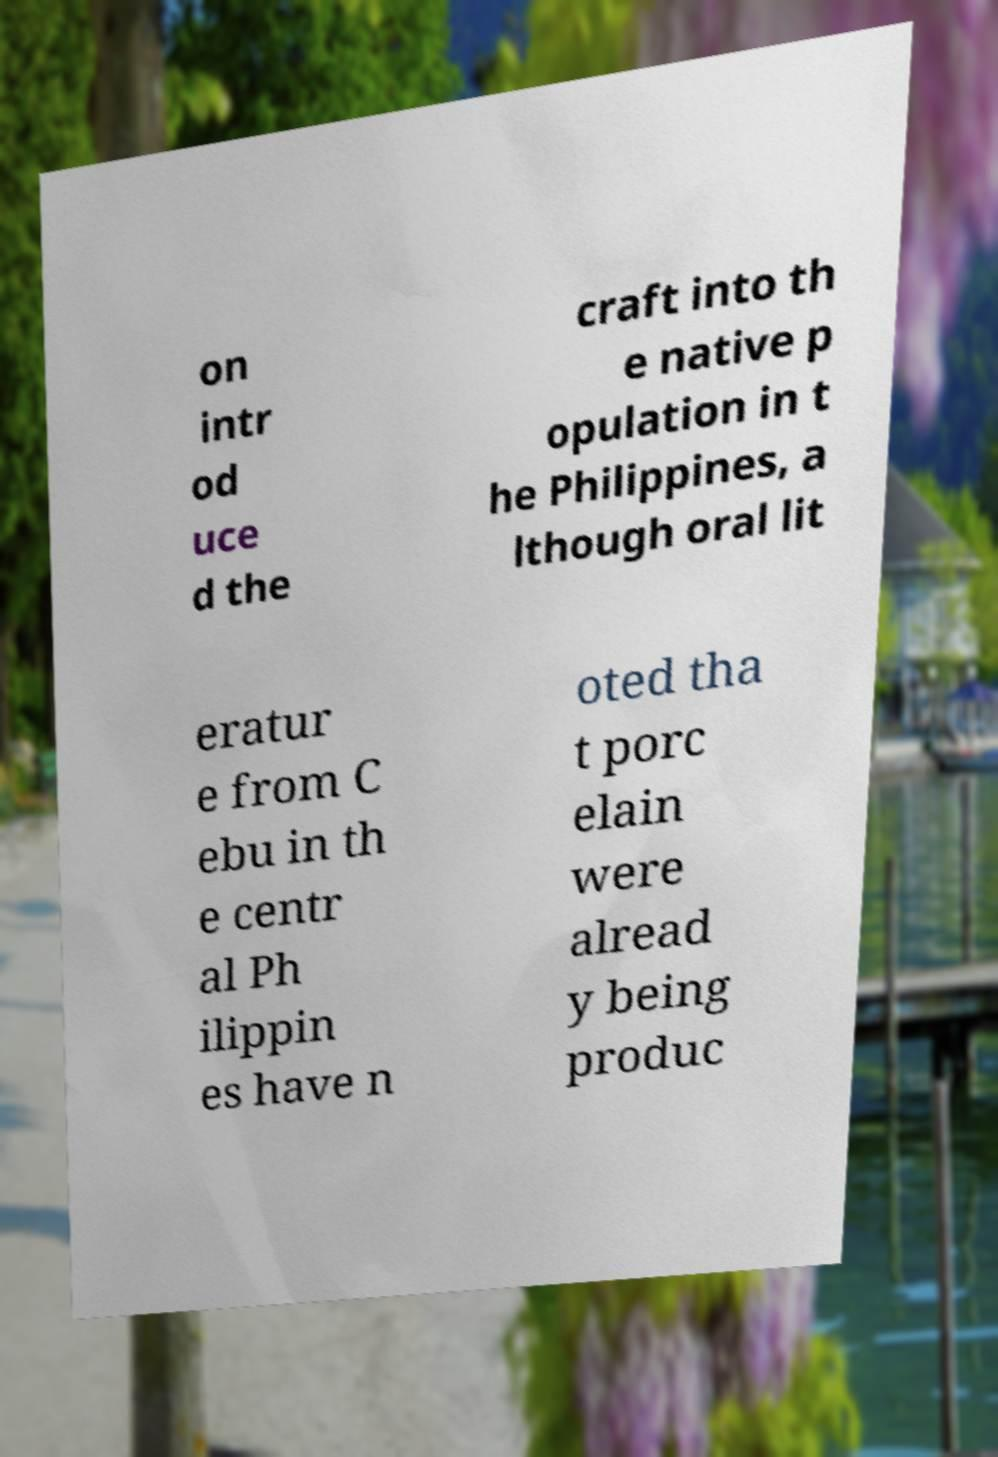I need the written content from this picture converted into text. Can you do that? on intr od uce d the craft into th e native p opulation in t he Philippines, a lthough oral lit eratur e from C ebu in th e centr al Ph ilippin es have n oted tha t porc elain were alread y being produc 